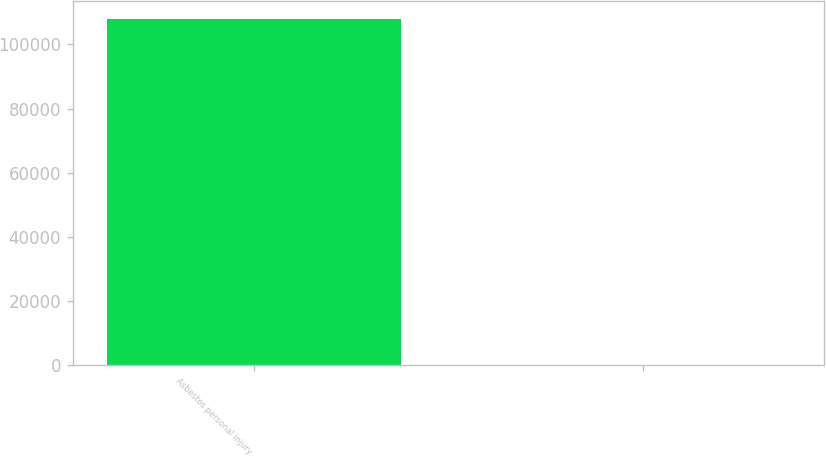Convert chart to OTSL. <chart><loc_0><loc_0><loc_500><loc_500><bar_chart><fcel>Asbestos personal injury<fcel>Unnamed: 1<nl><fcel>108000<fcel>85.5<nl></chart> 